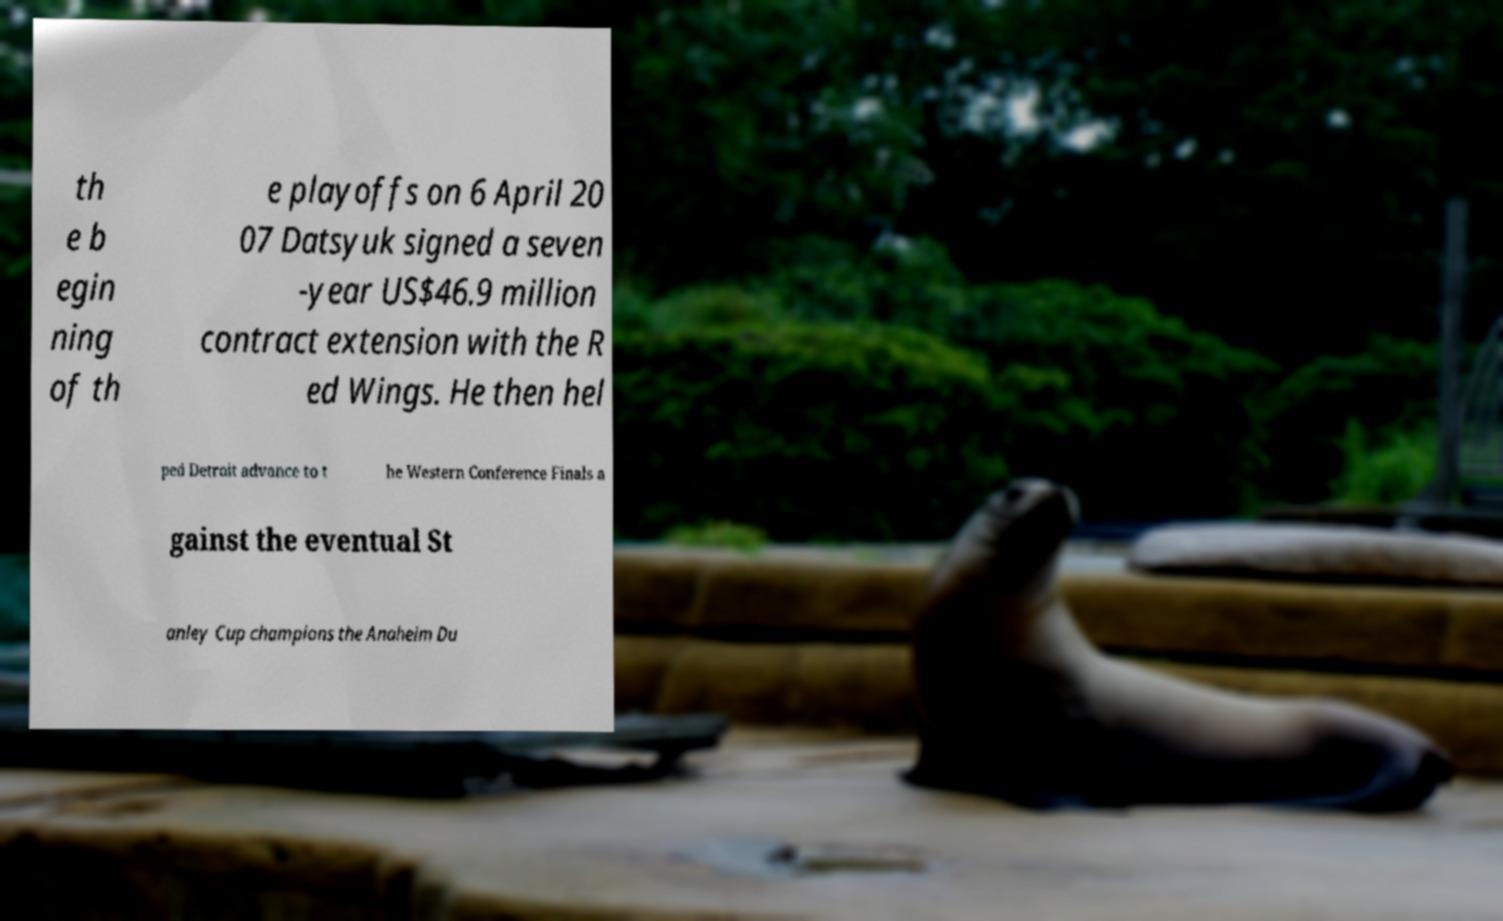Please read and relay the text visible in this image. What does it say? th e b egin ning of th e playoffs on 6 April 20 07 Datsyuk signed a seven -year US$46.9 million contract extension with the R ed Wings. He then hel ped Detroit advance to t he Western Conference Finals a gainst the eventual St anley Cup champions the Anaheim Du 